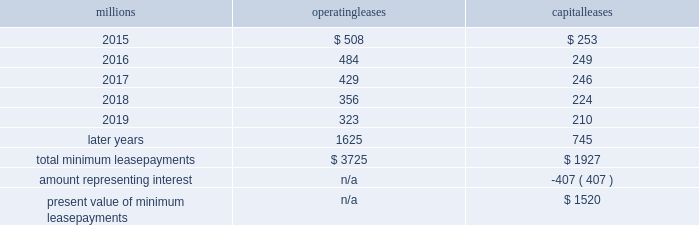Direct the activities of the vies and , therefore , do not control the ongoing activities that have a significant impact on the economic performance of the vies .
Additionally , we do not have the obligation to absorb losses of the vies or the right to receive benefits of the vies that could potentially be significant to the we are not considered to be the primary beneficiary and do not consolidate these vies because our actions and decisions do not have the most significant effect on the vie 2019s performance and our fixed-price purchase options are not considered to be potentially significant to the vies .
The future minimum lease payments associated with the vie leases totaled $ 3.0 billion as of december 31 , 2014 .
17 .
Leases we lease certain locomotives , freight cars , and other property .
The consolidated statements of financial position as of december 31 , 2014 and 2013 included $ 2454 million , net of $ 1210 million of accumulated depreciation , and $ 2486 million , net of $ 1092 million of accumulated depreciation , respectively , for properties held under capital leases .
A charge to income resulting from the depreciation for assets held under capital leases is included within depreciation expense in our consolidated statements of income .
Future minimum lease payments for operating and capital leases with initial or remaining non-cancelable lease terms in excess of one year as of december 31 , 2014 , were as follows : millions operating leases capital leases .
Approximately 95% ( 95 % ) of capital lease payments relate to locomotives .
Rent expense for operating leases with terms exceeding one month was $ 593 million in 2014 , $ 618 million in 2013 , and $ 631 million in 2012 .
When cash rental payments are not made on a straight-line basis , we recognize variable rental expense on a straight-line basis over the lease term .
Contingent rentals and sub-rentals are not significant .
18 .
Commitments and contingencies asserted and unasserted claims 2013 various claims and lawsuits are pending against us and certain of our subsidiaries .
We cannot fully determine the effect of all asserted and unasserted claims on our consolidated results of operations , financial condition , or liquidity ; however , to the extent possible , where asserted and unasserted claims are considered probable and where such claims can be reasonably estimated , we have recorded a liability .
We do not expect that any known lawsuits , claims , environmental costs , commitments , contingent liabilities , or guarantees will have a material adverse effect on our consolidated results of operations , financial condition , or liquidity after taking into account liabilities and insurance recoveries previously recorded for these matters .
Personal injury 2013 the cost of personal injuries to employees and others related to our activities is charged to expense based on estimates of the ultimate cost and number of incidents each year .
We use an actuarial analysis to measure the expense and liability , including unasserted claims .
The federal employers 2019 liability act ( fela ) governs compensation for work-related accidents .
Under fela , damages are assessed based on a finding of fault through litigation or out-of-court settlements .
We offer a comprehensive variety of services and rehabilitation programs for employees who are injured at work .
Our personal injury liability is not discounted to present value due to the uncertainty surrounding the timing of future payments .
Approximately 93% ( 93 % ) of the recorded liability is related to asserted claims and approximately 7% ( 7 % ) is related to unasserted claims at december 31 , 2014 .
Because of the uncertainty .
What percentage of total minimum lease payments are operating leases? 
Computations: (3725 / (3725 + 1927))
Answer: 0.65906. 